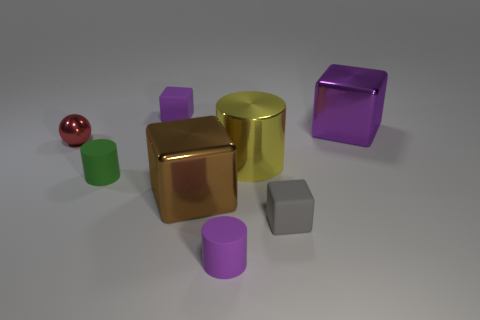Add 2 cyan matte things. How many objects exist? 10 Subtract all cylinders. How many objects are left? 5 Subtract 0 gray cylinders. How many objects are left? 8 Subtract all large brown shiny things. Subtract all yellow cylinders. How many objects are left? 6 Add 6 tiny gray cubes. How many tiny gray cubes are left? 7 Add 4 large cyan spheres. How many large cyan spheres exist? 4 